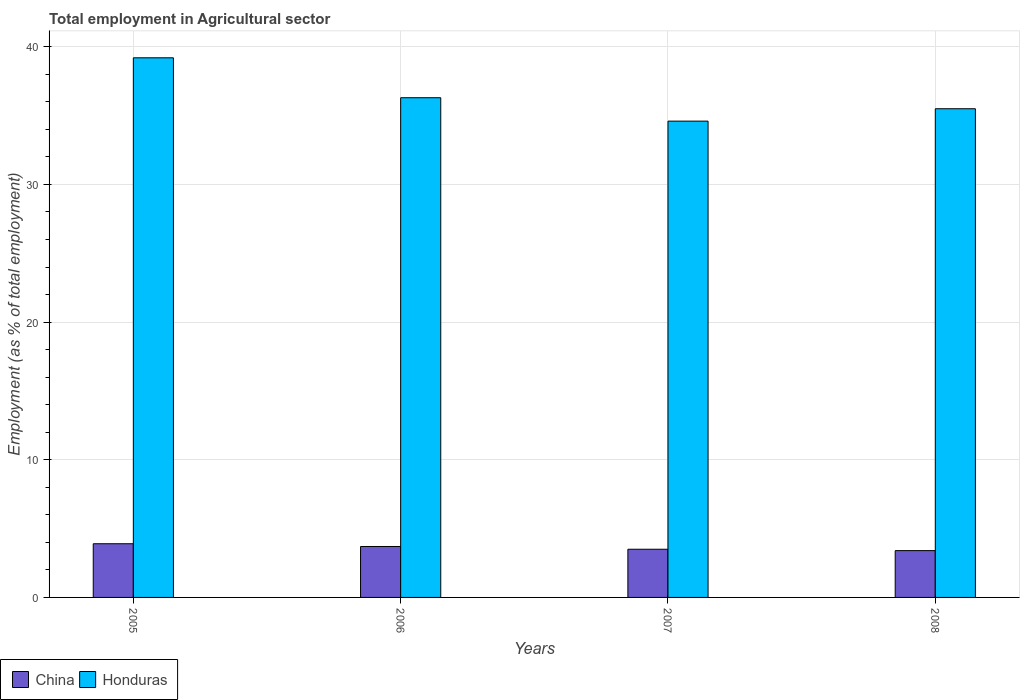How many groups of bars are there?
Provide a short and direct response. 4. Are the number of bars on each tick of the X-axis equal?
Provide a succinct answer. Yes. How many bars are there on the 1st tick from the right?
Offer a terse response. 2. What is the label of the 4th group of bars from the left?
Keep it short and to the point. 2008. What is the employment in agricultural sector in China in 2007?
Ensure brevity in your answer.  3.5. Across all years, what is the maximum employment in agricultural sector in China?
Your answer should be compact. 3.9. Across all years, what is the minimum employment in agricultural sector in Honduras?
Your answer should be very brief. 34.6. What is the total employment in agricultural sector in Honduras in the graph?
Keep it short and to the point. 145.6. What is the difference between the employment in agricultural sector in Honduras in 2006 and that in 2008?
Provide a short and direct response. 0.8. What is the difference between the employment in agricultural sector in China in 2005 and the employment in agricultural sector in Honduras in 2006?
Offer a terse response. -32.4. What is the average employment in agricultural sector in Honduras per year?
Ensure brevity in your answer.  36.4. In the year 2006, what is the difference between the employment in agricultural sector in Honduras and employment in agricultural sector in China?
Keep it short and to the point. 32.6. What is the ratio of the employment in agricultural sector in Honduras in 2006 to that in 2008?
Your response must be concise. 1.02. Is the employment in agricultural sector in China in 2005 less than that in 2007?
Keep it short and to the point. No. What is the difference between the highest and the second highest employment in agricultural sector in Honduras?
Your answer should be compact. 2.9. Is the sum of the employment in agricultural sector in Honduras in 2006 and 2008 greater than the maximum employment in agricultural sector in China across all years?
Provide a short and direct response. Yes. What does the 2nd bar from the left in 2007 represents?
Provide a succinct answer. Honduras. How many bars are there?
Your response must be concise. 8. Are all the bars in the graph horizontal?
Your answer should be very brief. No. How many years are there in the graph?
Make the answer very short. 4. What is the difference between two consecutive major ticks on the Y-axis?
Keep it short and to the point. 10. Are the values on the major ticks of Y-axis written in scientific E-notation?
Ensure brevity in your answer.  No. Does the graph contain any zero values?
Offer a very short reply. No. Does the graph contain grids?
Give a very brief answer. Yes. How many legend labels are there?
Offer a very short reply. 2. What is the title of the graph?
Provide a short and direct response. Total employment in Agricultural sector. What is the label or title of the Y-axis?
Keep it short and to the point. Employment (as % of total employment). What is the Employment (as % of total employment) of China in 2005?
Your answer should be compact. 3.9. What is the Employment (as % of total employment) of Honduras in 2005?
Give a very brief answer. 39.2. What is the Employment (as % of total employment) of China in 2006?
Offer a very short reply. 3.7. What is the Employment (as % of total employment) of Honduras in 2006?
Provide a succinct answer. 36.3. What is the Employment (as % of total employment) in China in 2007?
Keep it short and to the point. 3.5. What is the Employment (as % of total employment) in Honduras in 2007?
Give a very brief answer. 34.6. What is the Employment (as % of total employment) in China in 2008?
Your answer should be compact. 3.4. What is the Employment (as % of total employment) in Honduras in 2008?
Give a very brief answer. 35.5. Across all years, what is the maximum Employment (as % of total employment) of China?
Make the answer very short. 3.9. Across all years, what is the maximum Employment (as % of total employment) in Honduras?
Ensure brevity in your answer.  39.2. Across all years, what is the minimum Employment (as % of total employment) of China?
Provide a succinct answer. 3.4. Across all years, what is the minimum Employment (as % of total employment) in Honduras?
Provide a short and direct response. 34.6. What is the total Employment (as % of total employment) of China in the graph?
Provide a short and direct response. 14.5. What is the total Employment (as % of total employment) in Honduras in the graph?
Your answer should be compact. 145.6. What is the difference between the Employment (as % of total employment) of Honduras in 2005 and that in 2006?
Make the answer very short. 2.9. What is the difference between the Employment (as % of total employment) in China in 2006 and that in 2007?
Your response must be concise. 0.2. What is the difference between the Employment (as % of total employment) in China in 2006 and that in 2008?
Your answer should be very brief. 0.3. What is the difference between the Employment (as % of total employment) in Honduras in 2006 and that in 2008?
Give a very brief answer. 0.8. What is the difference between the Employment (as % of total employment) of China in 2007 and that in 2008?
Ensure brevity in your answer.  0.1. What is the difference between the Employment (as % of total employment) of Honduras in 2007 and that in 2008?
Ensure brevity in your answer.  -0.9. What is the difference between the Employment (as % of total employment) in China in 2005 and the Employment (as % of total employment) in Honduras in 2006?
Make the answer very short. -32.4. What is the difference between the Employment (as % of total employment) in China in 2005 and the Employment (as % of total employment) in Honduras in 2007?
Offer a very short reply. -30.7. What is the difference between the Employment (as % of total employment) of China in 2005 and the Employment (as % of total employment) of Honduras in 2008?
Your answer should be compact. -31.6. What is the difference between the Employment (as % of total employment) in China in 2006 and the Employment (as % of total employment) in Honduras in 2007?
Ensure brevity in your answer.  -30.9. What is the difference between the Employment (as % of total employment) in China in 2006 and the Employment (as % of total employment) in Honduras in 2008?
Keep it short and to the point. -31.8. What is the difference between the Employment (as % of total employment) in China in 2007 and the Employment (as % of total employment) in Honduras in 2008?
Offer a very short reply. -32. What is the average Employment (as % of total employment) in China per year?
Ensure brevity in your answer.  3.62. What is the average Employment (as % of total employment) of Honduras per year?
Provide a succinct answer. 36.4. In the year 2005, what is the difference between the Employment (as % of total employment) of China and Employment (as % of total employment) of Honduras?
Keep it short and to the point. -35.3. In the year 2006, what is the difference between the Employment (as % of total employment) of China and Employment (as % of total employment) of Honduras?
Your answer should be very brief. -32.6. In the year 2007, what is the difference between the Employment (as % of total employment) of China and Employment (as % of total employment) of Honduras?
Keep it short and to the point. -31.1. In the year 2008, what is the difference between the Employment (as % of total employment) in China and Employment (as % of total employment) in Honduras?
Your answer should be very brief. -32.1. What is the ratio of the Employment (as % of total employment) in China in 2005 to that in 2006?
Your answer should be compact. 1.05. What is the ratio of the Employment (as % of total employment) in Honduras in 2005 to that in 2006?
Your response must be concise. 1.08. What is the ratio of the Employment (as % of total employment) in China in 2005 to that in 2007?
Your answer should be very brief. 1.11. What is the ratio of the Employment (as % of total employment) in Honduras in 2005 to that in 2007?
Give a very brief answer. 1.13. What is the ratio of the Employment (as % of total employment) of China in 2005 to that in 2008?
Your answer should be compact. 1.15. What is the ratio of the Employment (as % of total employment) of Honduras in 2005 to that in 2008?
Keep it short and to the point. 1.1. What is the ratio of the Employment (as % of total employment) in China in 2006 to that in 2007?
Offer a terse response. 1.06. What is the ratio of the Employment (as % of total employment) in Honduras in 2006 to that in 2007?
Your answer should be very brief. 1.05. What is the ratio of the Employment (as % of total employment) in China in 2006 to that in 2008?
Your answer should be compact. 1.09. What is the ratio of the Employment (as % of total employment) of Honduras in 2006 to that in 2008?
Keep it short and to the point. 1.02. What is the ratio of the Employment (as % of total employment) in China in 2007 to that in 2008?
Give a very brief answer. 1.03. What is the ratio of the Employment (as % of total employment) in Honduras in 2007 to that in 2008?
Your response must be concise. 0.97. What is the difference between the highest and the second highest Employment (as % of total employment) in Honduras?
Make the answer very short. 2.9. What is the difference between the highest and the lowest Employment (as % of total employment) of Honduras?
Offer a very short reply. 4.6. 